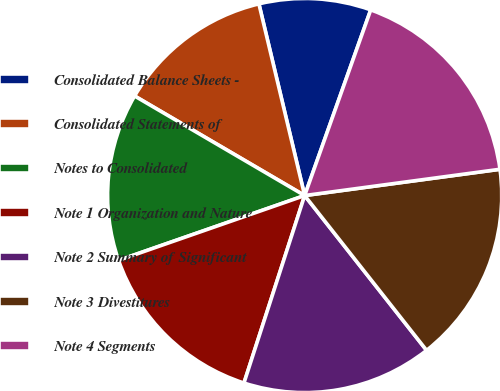<chart> <loc_0><loc_0><loc_500><loc_500><pie_chart><fcel>Consolidated Balance Sheets -<fcel>Consolidated Statements of<fcel>Notes to Consolidated<fcel>Note 1 Organization and Nature<fcel>Note 2 Summary of Significant<fcel>Note 3 Divestitures<fcel>Note 4 Segments<nl><fcel>9.17%<fcel>12.84%<fcel>13.76%<fcel>14.68%<fcel>15.6%<fcel>16.51%<fcel>17.43%<nl></chart> 